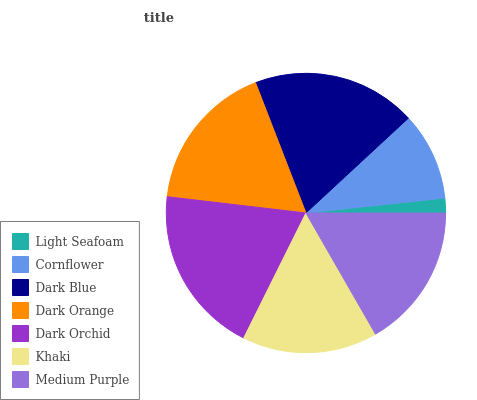Is Light Seafoam the minimum?
Answer yes or no. Yes. Is Dark Orchid the maximum?
Answer yes or no. Yes. Is Cornflower the minimum?
Answer yes or no. No. Is Cornflower the maximum?
Answer yes or no. No. Is Cornflower greater than Light Seafoam?
Answer yes or no. Yes. Is Light Seafoam less than Cornflower?
Answer yes or no. Yes. Is Light Seafoam greater than Cornflower?
Answer yes or no. No. Is Cornflower less than Light Seafoam?
Answer yes or no. No. Is Medium Purple the high median?
Answer yes or no. Yes. Is Medium Purple the low median?
Answer yes or no. Yes. Is Dark Orange the high median?
Answer yes or no. No. Is Dark Orange the low median?
Answer yes or no. No. 